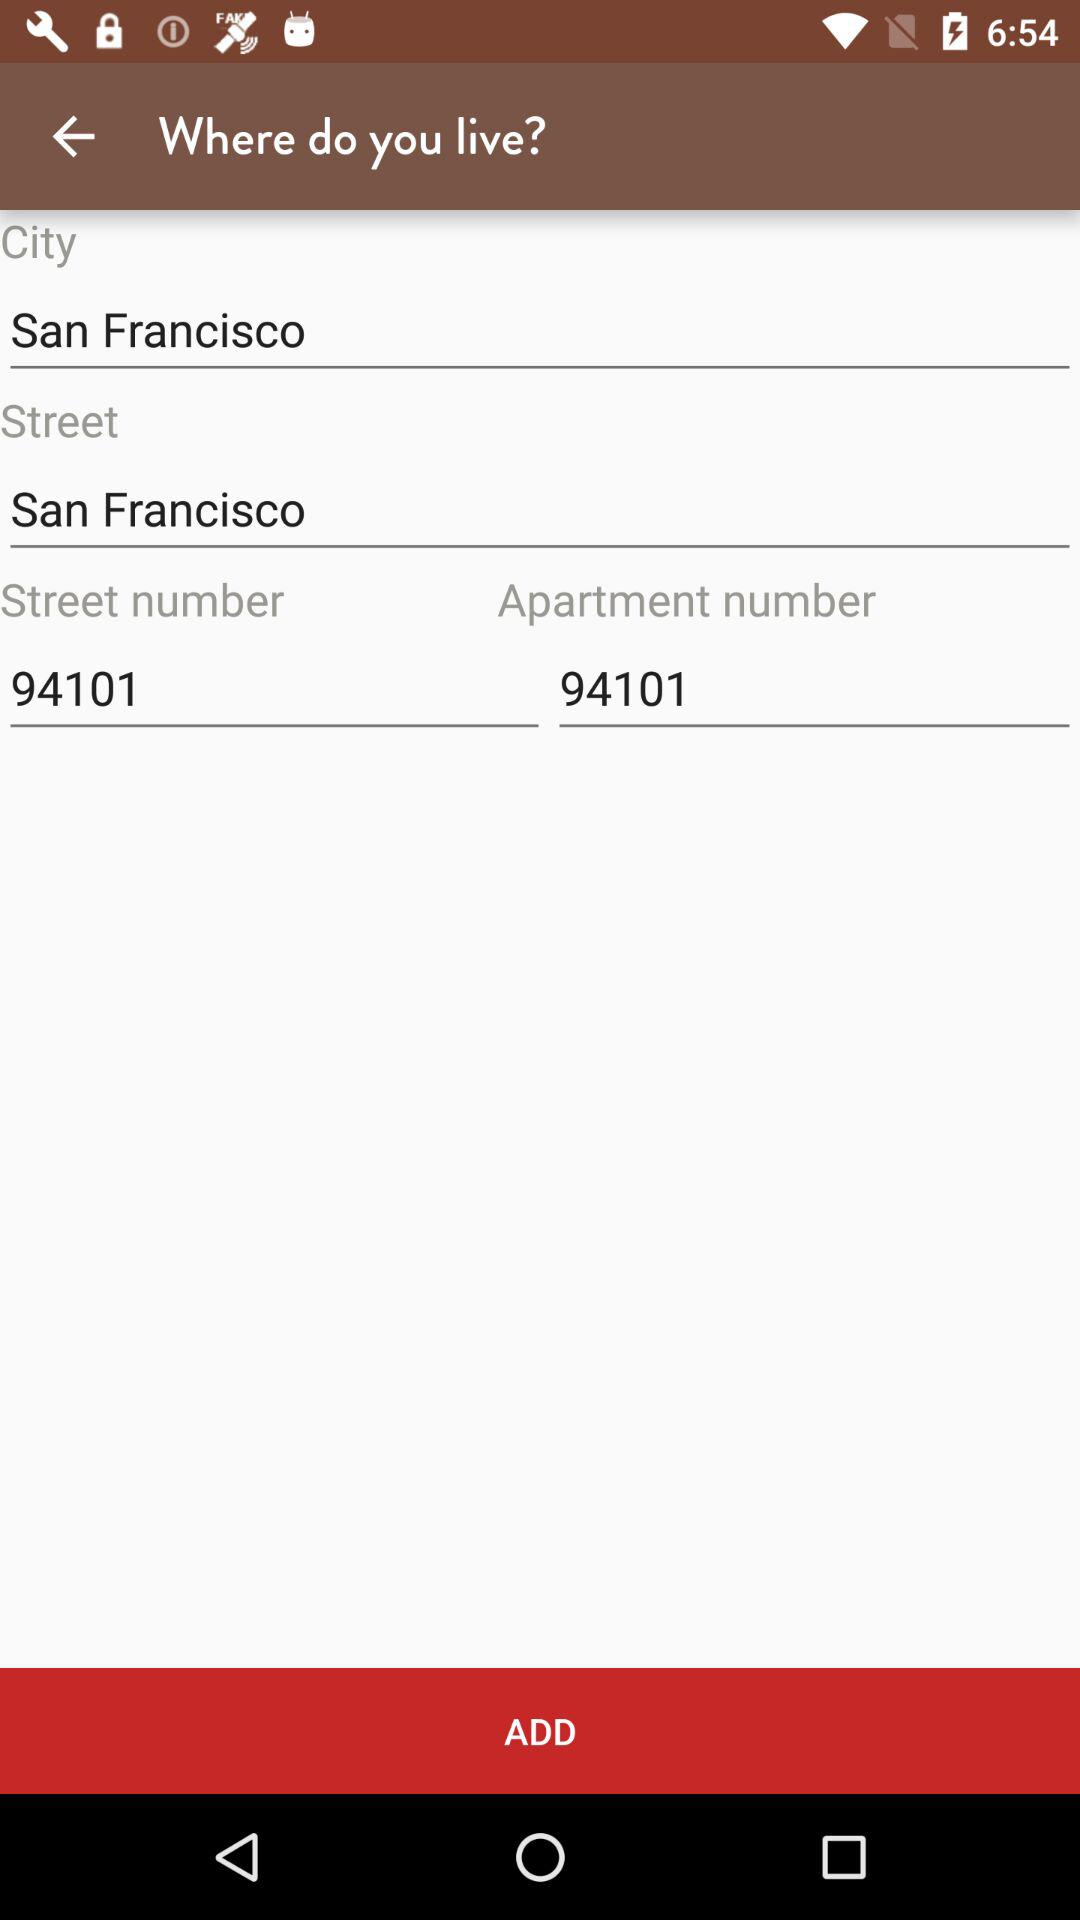What is the street number? The street number is 94101. 